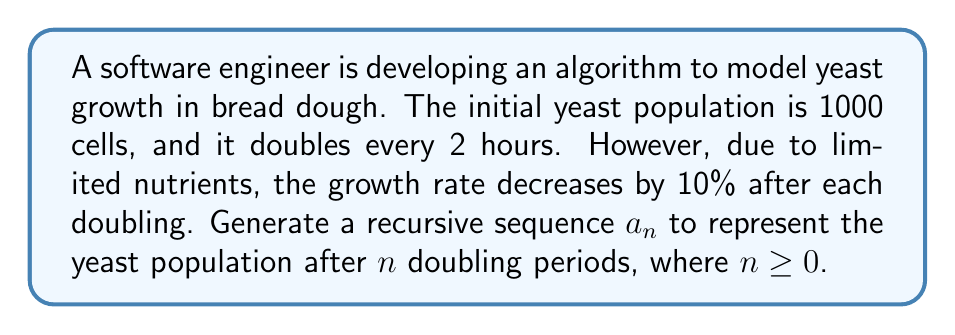Provide a solution to this math problem. Let's approach this step-by-step:

1) First, we need to define the initial condition:
   $a_0 = 1000$ (initial yeast population)

2) For the first doubling period ($n = 1$):
   $a_1 = a_0 \cdot 2 = 1000 \cdot 2 = 2000$

3) For the second doubling period ($n = 2$), we need to consider the 10% decrease in growth rate:
   $a_2 = a_1 \cdot 2 \cdot 0.9 = 2000 \cdot 2 \cdot 0.9 = 3600$

4) We can observe the pattern forming. For any $n > 0$:
   $a_n = a_{n-1} \cdot 2 \cdot (0.9)^{n-1}$

5) This can be written as a recursive sequence:

   $$a_n = \begin{cases}
   1000 & \text{if } n = 0 \\
   2a_{n-1} \cdot (0.9)^{n-1} & \text{if } n > 0
   \end{cases}$$

This recursive sequence models the yeast population after $n$ doubling periods, taking into account the initial population, doubling growth, and the decreasing growth rate due to limited nutrients.
Answer: $$a_n = \begin{cases}
1000 & \text{if } n = 0 \\
2a_{n-1} \cdot (0.9)^{n-1} & \text{if } n > 0
\end{cases}$$ 